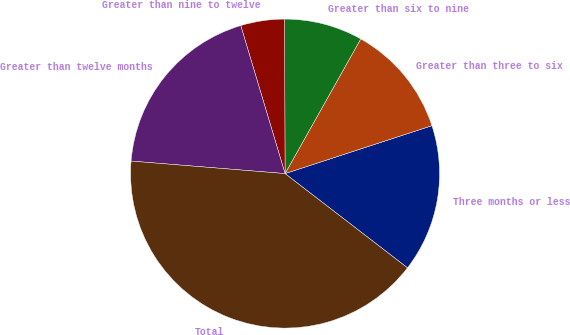Convert chart. <chart><loc_0><loc_0><loc_500><loc_500><pie_chart><fcel>Three months or less<fcel>Greater than three to six<fcel>Greater than six to nine<fcel>Greater than nine to twelve<fcel>Greater than twelve months<fcel>Total<nl><fcel>15.46%<fcel>11.83%<fcel>8.2%<fcel>4.58%<fcel>19.08%<fcel>40.85%<nl></chart> 